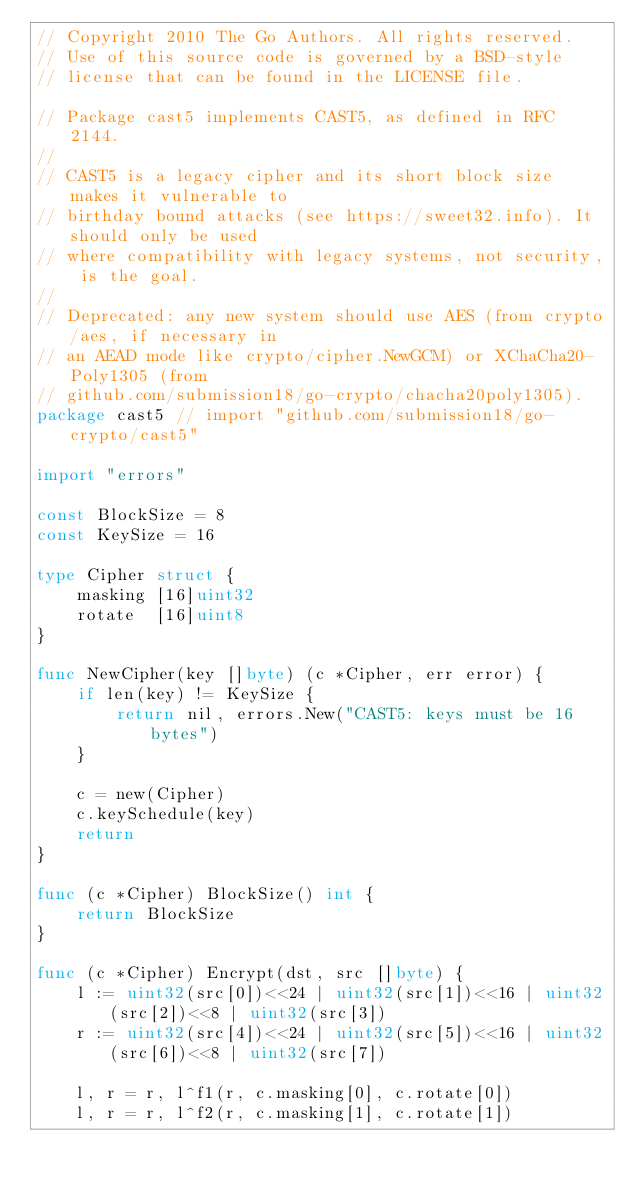<code> <loc_0><loc_0><loc_500><loc_500><_Go_>// Copyright 2010 The Go Authors. All rights reserved.
// Use of this source code is governed by a BSD-style
// license that can be found in the LICENSE file.

// Package cast5 implements CAST5, as defined in RFC 2144.
//
// CAST5 is a legacy cipher and its short block size makes it vulnerable to
// birthday bound attacks (see https://sweet32.info). It should only be used
// where compatibility with legacy systems, not security, is the goal.
//
// Deprecated: any new system should use AES (from crypto/aes, if necessary in
// an AEAD mode like crypto/cipher.NewGCM) or XChaCha20-Poly1305 (from
// github.com/submission18/go-crypto/chacha20poly1305).
package cast5 // import "github.com/submission18/go-crypto/cast5"

import "errors"

const BlockSize = 8
const KeySize = 16

type Cipher struct {
	masking [16]uint32
	rotate  [16]uint8
}

func NewCipher(key []byte) (c *Cipher, err error) {
	if len(key) != KeySize {
		return nil, errors.New("CAST5: keys must be 16 bytes")
	}

	c = new(Cipher)
	c.keySchedule(key)
	return
}

func (c *Cipher) BlockSize() int {
	return BlockSize
}

func (c *Cipher) Encrypt(dst, src []byte) {
	l := uint32(src[0])<<24 | uint32(src[1])<<16 | uint32(src[2])<<8 | uint32(src[3])
	r := uint32(src[4])<<24 | uint32(src[5])<<16 | uint32(src[6])<<8 | uint32(src[7])

	l, r = r, l^f1(r, c.masking[0], c.rotate[0])
	l, r = r, l^f2(r, c.masking[1], c.rotate[1])</code> 